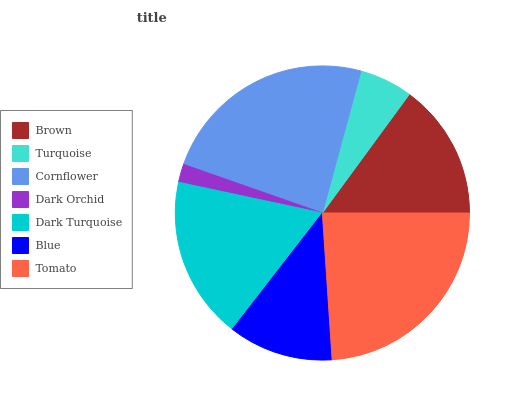Is Dark Orchid the minimum?
Answer yes or no. Yes. Is Tomato the maximum?
Answer yes or no. Yes. Is Turquoise the minimum?
Answer yes or no. No. Is Turquoise the maximum?
Answer yes or no. No. Is Brown greater than Turquoise?
Answer yes or no. Yes. Is Turquoise less than Brown?
Answer yes or no. Yes. Is Turquoise greater than Brown?
Answer yes or no. No. Is Brown less than Turquoise?
Answer yes or no. No. Is Brown the high median?
Answer yes or no. Yes. Is Brown the low median?
Answer yes or no. Yes. Is Cornflower the high median?
Answer yes or no. No. Is Blue the low median?
Answer yes or no. No. 